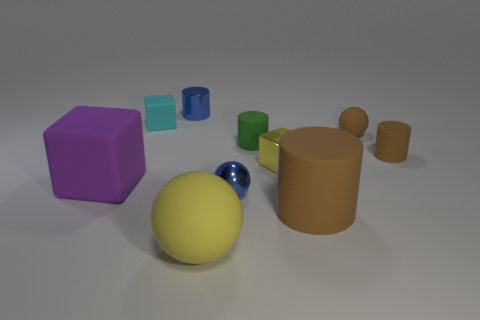There is a tiny brown object that is the same shape as the small green matte object; what is it made of?
Give a very brief answer. Rubber. What is the object that is both in front of the metal sphere and right of the yellow block made of?
Offer a terse response. Rubber. How many big objects are yellow rubber cylinders or yellow shiny cubes?
Provide a short and direct response. 0. What shape is the big thing that is the same color as the tiny rubber sphere?
Ensure brevity in your answer.  Cylinder. Are the object in front of the large brown thing and the small yellow block made of the same material?
Your answer should be compact. No. There is a brown cylinder on the left side of the matte cylinder that is on the right side of the large brown object; what is its material?
Your answer should be very brief. Rubber. What number of big brown things are the same shape as the tiny green thing?
Offer a very short reply. 1. What size is the rubber ball that is in front of the brown cylinder in front of the tiny brown matte thing in front of the green object?
Offer a terse response. Large. What number of purple things are tiny cubes or tiny metal things?
Your answer should be compact. 0. Does the small yellow metal thing that is left of the big brown cylinder have the same shape as the large purple thing?
Give a very brief answer. Yes. 